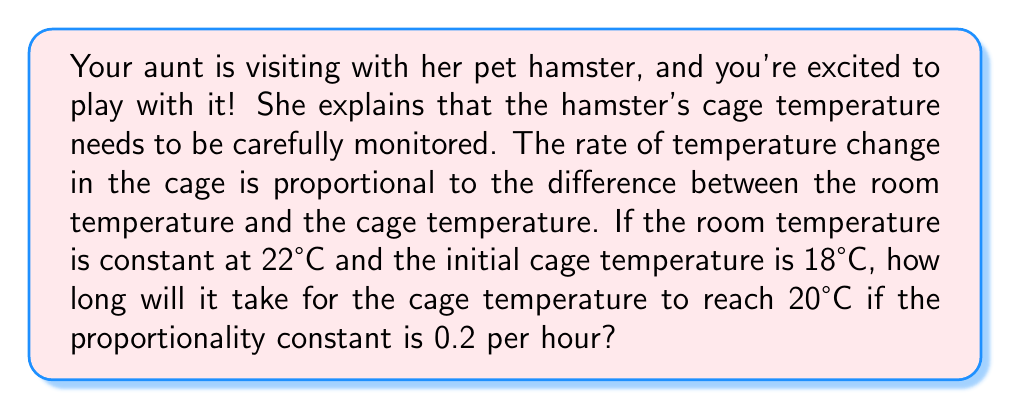Could you help me with this problem? Let's approach this step-by-step:

1) Let $T(t)$ be the temperature of the cage at time $t$ (in hours).

2) The rate of temperature change is given by:

   $$\frac{dT}{dt} = k(T_r - T)$$

   where $k$ is the proportionality constant and $T_r$ is the room temperature.

3) We're given:
   - $k = 0.2$ per hour
   - $T_r = 22°C$
   - Initial temperature $T(0) = 18°C$
   - We want to find $t$ when $T(t) = 20°C$

4) Separating variables:

   $$\frac{dT}{T_r - T} = k dt$$

5) Integrating both sides:

   $$\int_{18}^{20} \frac{dT}{22 - T} = \int_{0}^{t} 0.2 dt$$

6) Solving the left side:
   
   $$[-\ln(22-T)]_{18}^{20} = 0.2t$$

7) Evaluating:

   $$-\ln(22-20) + \ln(22-18) = 0.2t$$
   $$-\ln(2) + \ln(4) = 0.2t$$
   $$\ln(2) = 0.2t$$

8) Solving for $t$:

   $$t = \frac{\ln(2)}{0.2} \approx 3.47$$

Therefore, it will take approximately 3.47 hours for the cage to reach 20°C.
Answer: $t \approx 3.47$ hours 